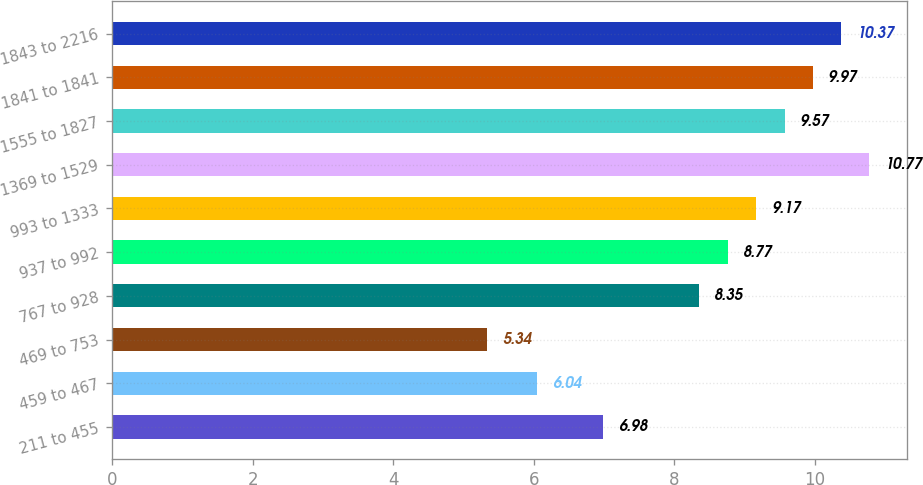<chart> <loc_0><loc_0><loc_500><loc_500><bar_chart><fcel>211 to 455<fcel>459 to 467<fcel>469 to 753<fcel>767 to 928<fcel>937 to 992<fcel>993 to 1333<fcel>1369 to 1529<fcel>1555 to 1827<fcel>1841 to 1841<fcel>1843 to 2216<nl><fcel>6.98<fcel>6.04<fcel>5.34<fcel>8.35<fcel>8.77<fcel>9.17<fcel>10.77<fcel>9.57<fcel>9.97<fcel>10.37<nl></chart> 